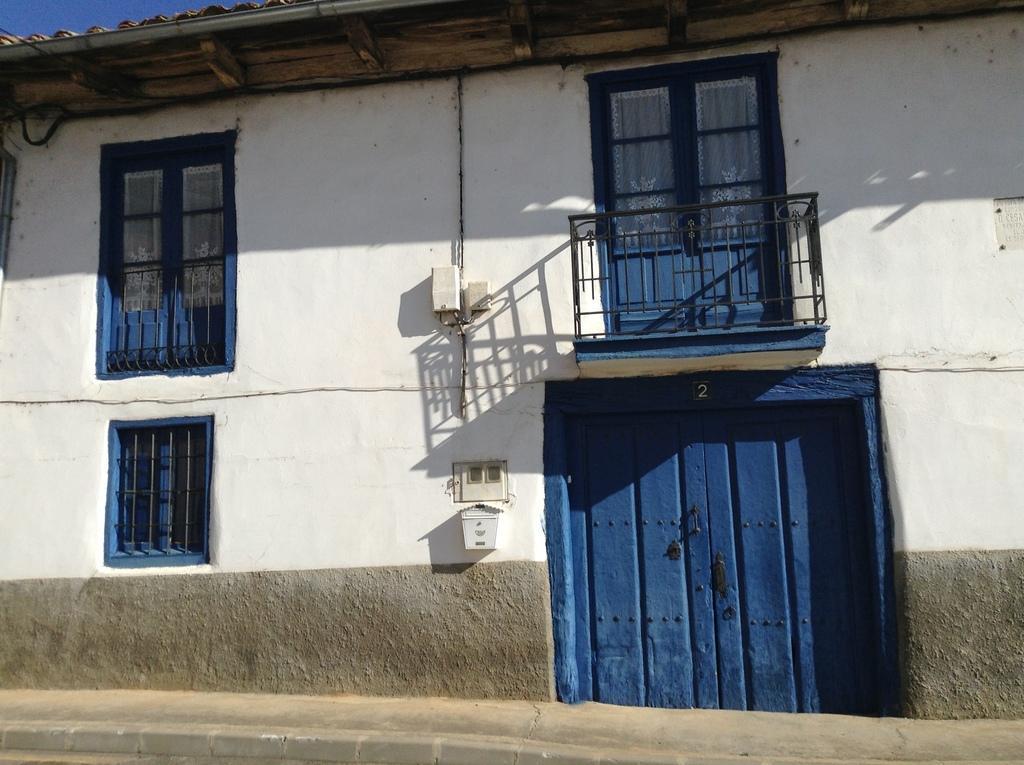How would you summarize this image in a sentence or two? In the picture we can see a house building with a white color wall and some windows which are blue in color and we can also see a door which is blue in color and just the top of the door, we can see another door with a railing and to the wall we can see a pipe and some box which is white in color and some part of the sky. 